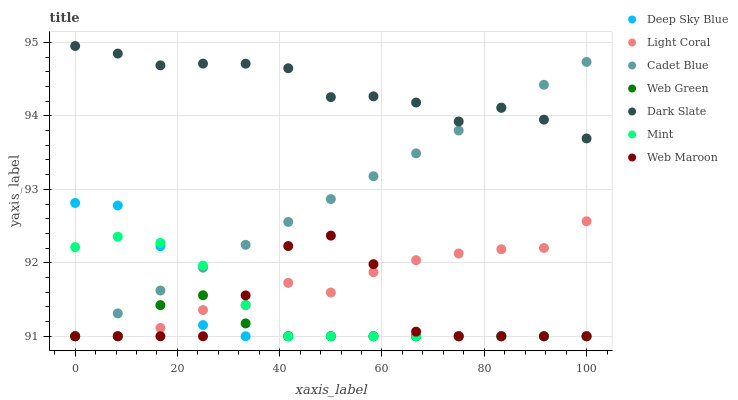Does Web Green have the minimum area under the curve?
Answer yes or no. Yes. Does Dark Slate have the maximum area under the curve?
Answer yes or no. Yes. Does Web Maroon have the minimum area under the curve?
Answer yes or no. No. Does Web Maroon have the maximum area under the curve?
Answer yes or no. No. Is Cadet Blue the smoothest?
Answer yes or no. Yes. Is Web Maroon the roughest?
Answer yes or no. Yes. Is Web Green the smoothest?
Answer yes or no. No. Is Web Green the roughest?
Answer yes or no. No. Does Cadet Blue have the lowest value?
Answer yes or no. Yes. Does Dark Slate have the lowest value?
Answer yes or no. No. Does Dark Slate have the highest value?
Answer yes or no. Yes. Does Web Maroon have the highest value?
Answer yes or no. No. Is Web Green less than Dark Slate?
Answer yes or no. Yes. Is Dark Slate greater than Web Maroon?
Answer yes or no. Yes. Does Web Green intersect Mint?
Answer yes or no. Yes. Is Web Green less than Mint?
Answer yes or no. No. Is Web Green greater than Mint?
Answer yes or no. No. Does Web Green intersect Dark Slate?
Answer yes or no. No. 